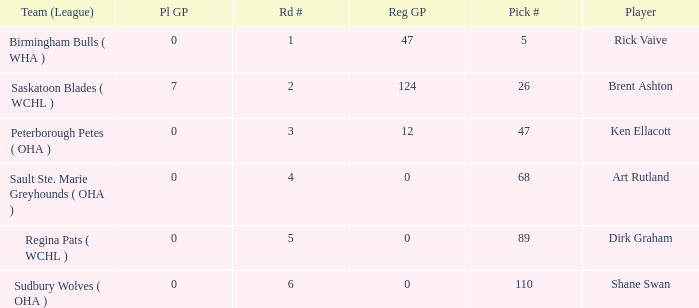How many reg GP for rick vaive in round 1? None. 